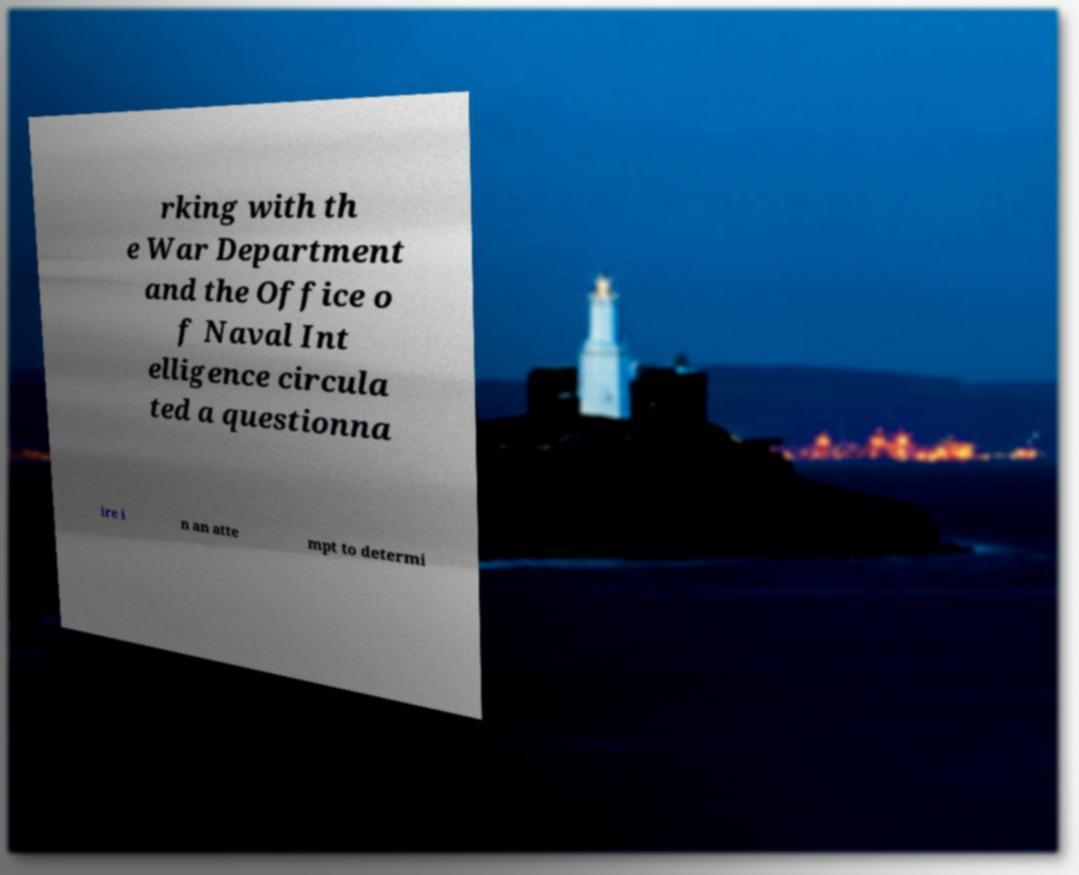Could you assist in decoding the text presented in this image and type it out clearly? rking with th e War Department and the Office o f Naval Int elligence circula ted a questionna ire i n an atte mpt to determi 